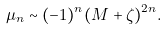<formula> <loc_0><loc_0><loc_500><loc_500>\mu _ { n } \sim ( - 1 ) ^ { n } ( M + \zeta ) ^ { 2 n } .</formula> 